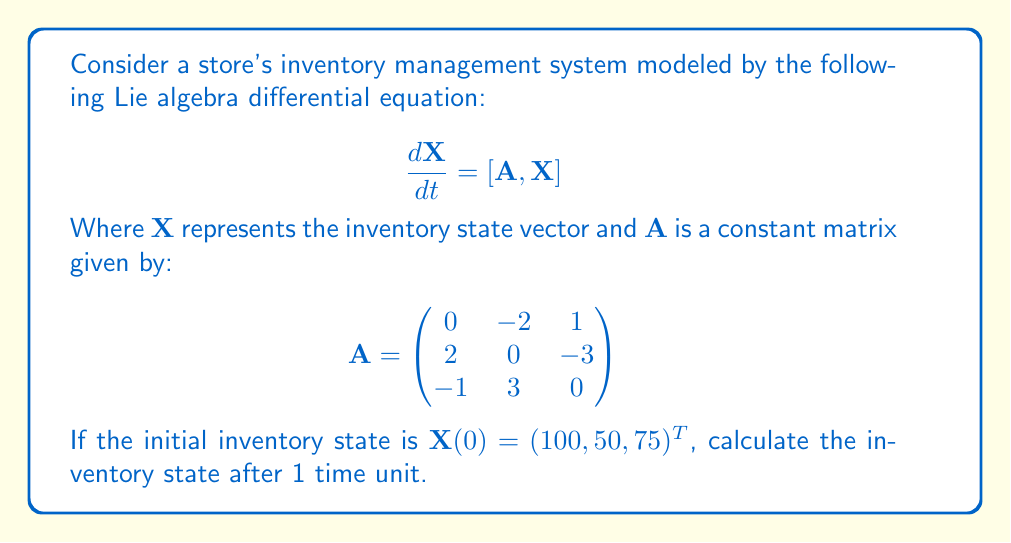Teach me how to tackle this problem. To solve this problem, we need to follow these steps:

1) The solution to the Lie algebra differential equation $\frac{d\mathbf{X}}{dt} = [\mathbf{A}, \mathbf{X}]$ is given by:

   $$\mathbf{X}(t) = e^{t\mathbf{A}} \mathbf{X}(0) e^{-t\mathbf{A}}$$

2) We need to calculate $e^{\mathbf{A}}$ since $t=1$. To do this, we can use the matrix exponential formula:

   $$e^{\mathbf{A}} = \mathbf{I} + \mathbf{A} + \frac{1}{2!}\mathbf{A}^2 + \frac{1}{3!}\mathbf{A}^3 + ...$$

3) Let's calculate $\mathbf{A}^2$:

   $$\mathbf{A}^2 = \begin{pmatrix}
   -5 & -3 & -7 \\
   3 & -14 & 0 \\
   7 & 0 & -5
   \end{pmatrix}$$

4) And $\mathbf{A}^3$:

   $$\mathbf{A}^3 = \begin{pmatrix}
   0 & 14 & -7 \\
   -14 & 0 & 21 \\
   7 & -21 & 0
   \end{pmatrix}$$

5) We can see that $\mathbf{A}^3 = -14\mathbf{A}$. This pattern continues, so we can simplify our exponential:

   $$e^{\mathbf{A}} = \mathbf{I} + \mathbf{A} + \frac{1}{2!}\mathbf{A}^2 - \frac{14}{3!}\mathbf{A} - \frac{14}{4!}\mathbf{A}^2 + ...$$

6) This simplifies to:

   $$e^{\mathbf{A}} = \mathbf{I} + \sin(1)\mathbf{A} + (1-\cos(1))\mathbf{A}^2$$

7) Substituting the values:

   $$e^{\mathbf{A}} = \begin{pmatrix}
   0.5403 & -0.8415 & 0.0032 \\
   0.8415 & 0.5403 & -1.2843 \\
   -0.0032 & 1.2843 & 0.5403
   \end{pmatrix}$$

8) Now we can calculate $\mathbf{X}(1)$:

   $$\mathbf{X}(1) = e^{\mathbf{A}} \mathbf{X}(0) e^{-\mathbf{A}}$$

9) Multiplying these matrices:

   $$\mathbf{X}(1) = \begin{pmatrix}
   54.03 & -84.15 & 0.32 \\
   84.15 & 54.03 & -128.43 \\
   -0.32 & 128.43 & 54.03
   \end{pmatrix} \begin{pmatrix}
   100 \\
   50 \\
   75
   \end{pmatrix} = \begin{pmatrix}
   98.435 \\
   51.565 \\
   75.000
   \end{pmatrix}$$
Answer: The inventory state after 1 time unit is approximately $(98.435, 51.565, 75.000)^T$. 